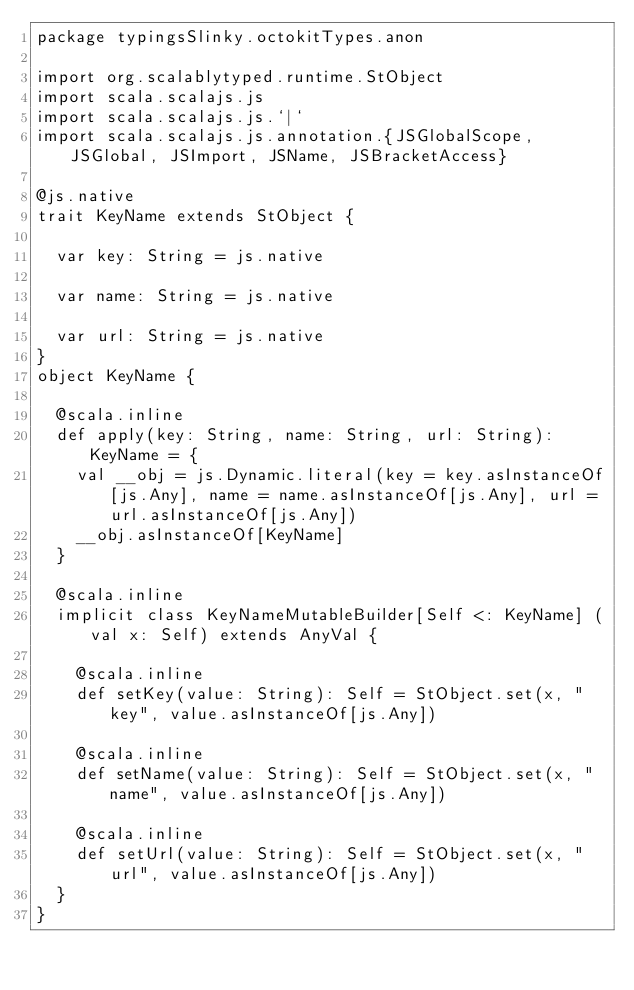Convert code to text. <code><loc_0><loc_0><loc_500><loc_500><_Scala_>package typingsSlinky.octokitTypes.anon

import org.scalablytyped.runtime.StObject
import scala.scalajs.js
import scala.scalajs.js.`|`
import scala.scalajs.js.annotation.{JSGlobalScope, JSGlobal, JSImport, JSName, JSBracketAccess}

@js.native
trait KeyName extends StObject {
  
  var key: String = js.native
  
  var name: String = js.native
  
  var url: String = js.native
}
object KeyName {
  
  @scala.inline
  def apply(key: String, name: String, url: String): KeyName = {
    val __obj = js.Dynamic.literal(key = key.asInstanceOf[js.Any], name = name.asInstanceOf[js.Any], url = url.asInstanceOf[js.Any])
    __obj.asInstanceOf[KeyName]
  }
  
  @scala.inline
  implicit class KeyNameMutableBuilder[Self <: KeyName] (val x: Self) extends AnyVal {
    
    @scala.inline
    def setKey(value: String): Self = StObject.set(x, "key", value.asInstanceOf[js.Any])
    
    @scala.inline
    def setName(value: String): Self = StObject.set(x, "name", value.asInstanceOf[js.Any])
    
    @scala.inline
    def setUrl(value: String): Self = StObject.set(x, "url", value.asInstanceOf[js.Any])
  }
}
</code> 